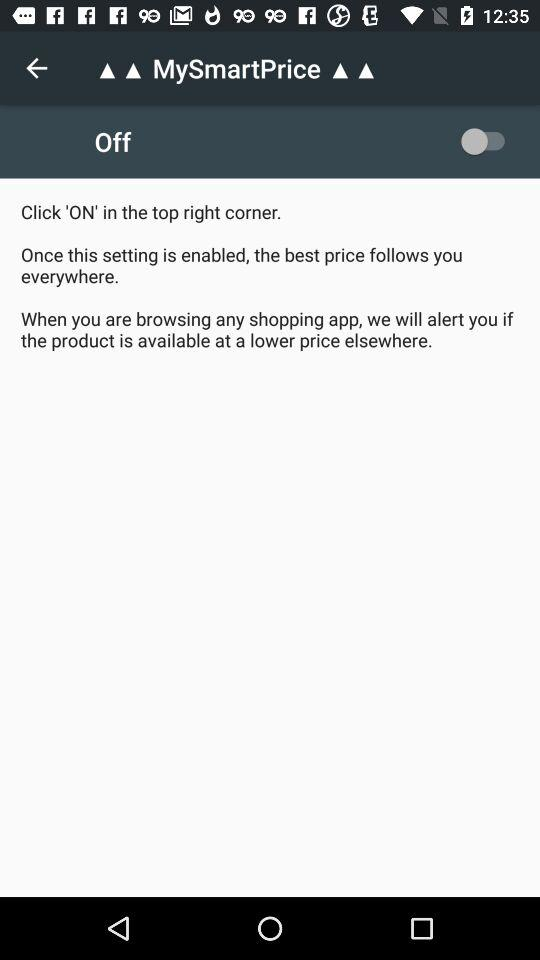What is the status of MySmartPrice? The status is off. 